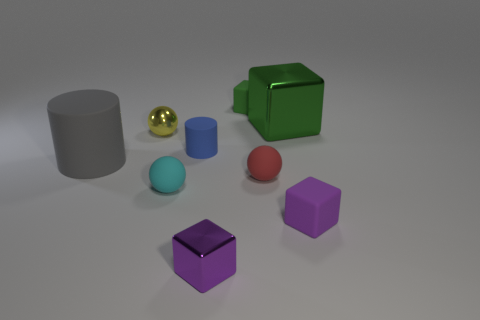Are there any blue rubber cylinders behind the small yellow shiny ball?
Your response must be concise. No. The object that is left of the purple metal object and in front of the small red matte thing has what shape?
Offer a terse response. Sphere. Are there any big brown shiny objects of the same shape as the gray thing?
Your response must be concise. No. There is a red rubber thing that is in front of the small yellow sphere; does it have the same size as the shiny ball behind the gray matte cylinder?
Provide a succinct answer. Yes. Are there more small yellow metallic spheres than green objects?
Provide a short and direct response. No. What number of purple blocks are the same material as the blue cylinder?
Offer a terse response. 1. Is the shape of the small cyan object the same as the purple rubber object?
Your answer should be compact. No. There is a purple object to the right of the big object that is to the right of the matte cylinder left of the cyan thing; what is its size?
Ensure brevity in your answer.  Small. Is there a tiny cube that is behind the big object that is on the right side of the small blue cylinder?
Your answer should be very brief. Yes. What number of tiny things are in front of the tiny metal thing on the right side of the rubber cylinder that is right of the big gray rubber thing?
Provide a succinct answer. 0. 